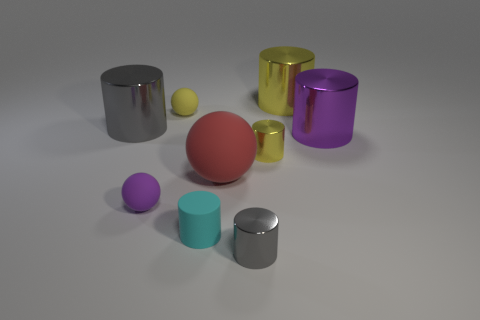How many other things are the same shape as the red object?
Give a very brief answer. 2. There is a tiny ball in front of the red matte sphere; what color is it?
Your answer should be very brief. Purple. Are the red object and the small gray object made of the same material?
Offer a terse response. No. What number of things are rubber cubes or purple things left of the large yellow metal thing?
Your answer should be compact. 1. There is a gray metallic object behind the tiny yellow cylinder; what is its shape?
Your response must be concise. Cylinder. There is a sphere right of the yellow ball; does it have the same size as the small cyan cylinder?
Ensure brevity in your answer.  No. Is there a yellow matte sphere that is on the left side of the gray cylinder in front of the purple cylinder?
Provide a short and direct response. Yes. Are there any tiny gray balls that have the same material as the tiny yellow cylinder?
Provide a succinct answer. No. What is the material of the tiny object to the right of the gray thing right of the big red object?
Offer a terse response. Metal. What is the cylinder that is to the left of the big rubber sphere and behind the tiny rubber cylinder made of?
Give a very brief answer. Metal. 